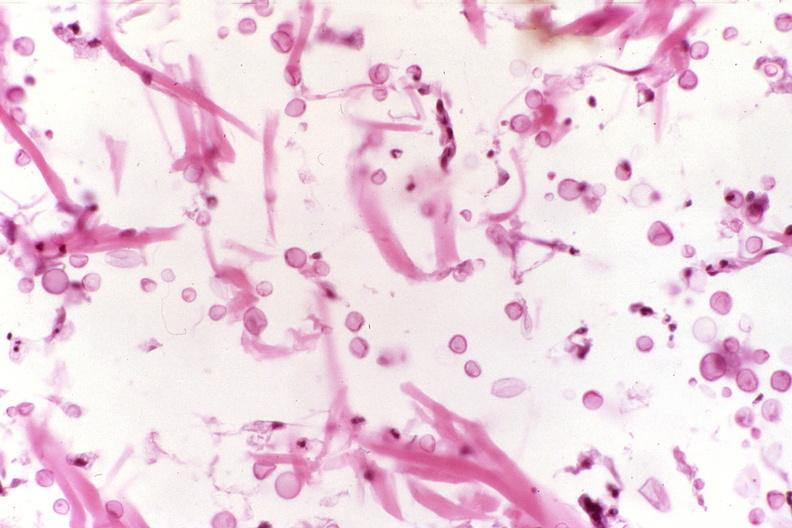what does this image show?
Answer the question using a single word or phrase. Cryptococcal dematitis 